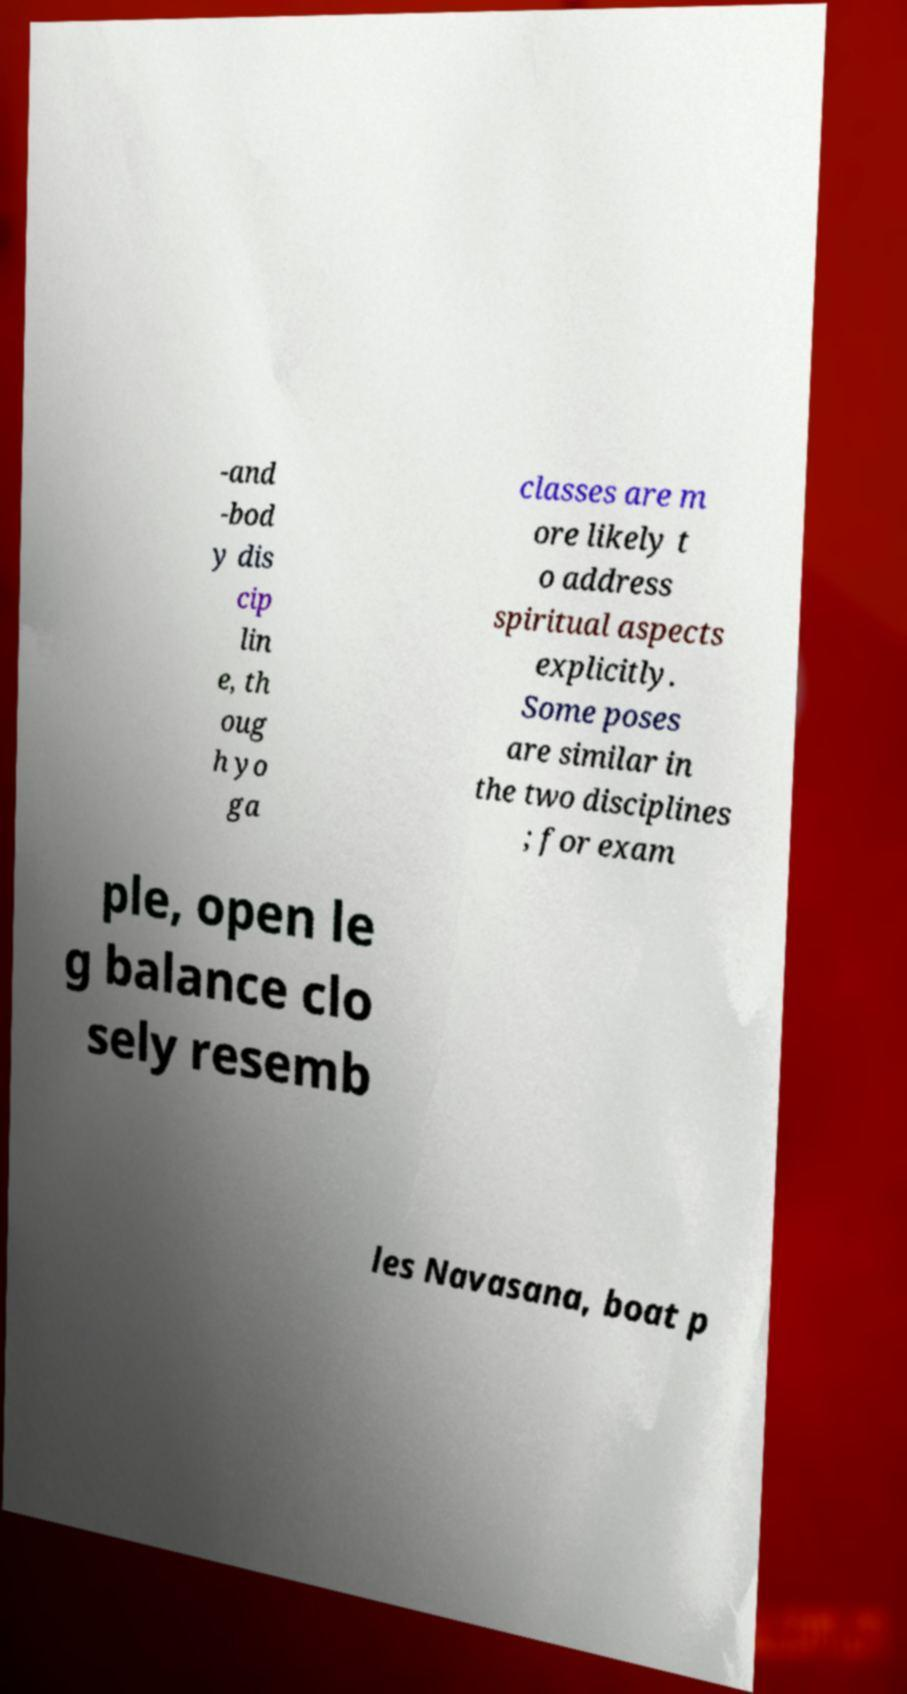Could you extract and type out the text from this image? -and -bod y dis cip lin e, th oug h yo ga classes are m ore likely t o address spiritual aspects explicitly. Some poses are similar in the two disciplines ; for exam ple, open le g balance clo sely resemb les Navasana, boat p 